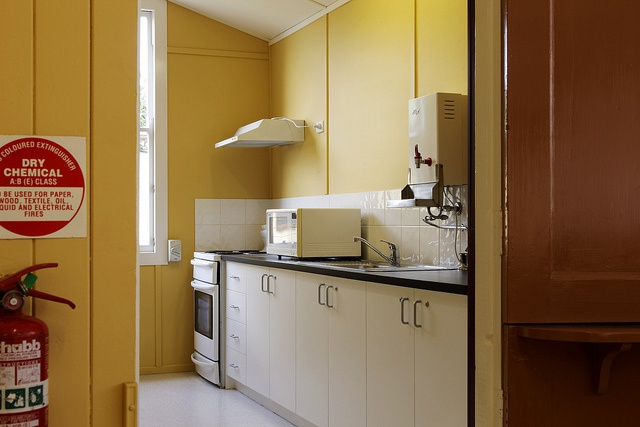Describe the objects in this image and their specific colors. I can see microwave in olive, tan, lightgray, and darkgray tones, oven in olive, darkgray, gray, black, and lavender tones, and sink in olive, darkgray, and gray tones in this image. 